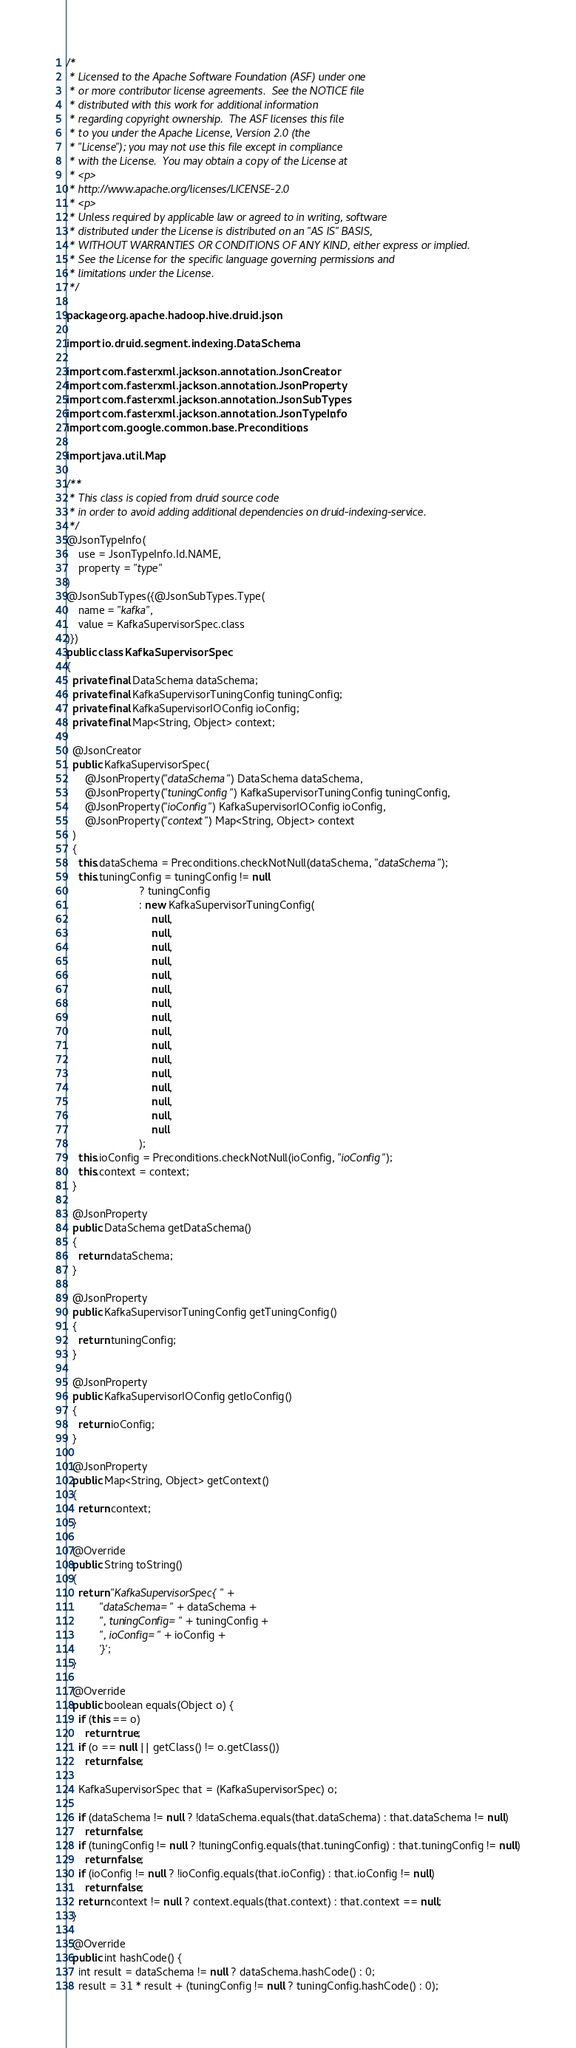<code> <loc_0><loc_0><loc_500><loc_500><_Java_>/*
 * Licensed to the Apache Software Foundation (ASF) under one
 * or more contributor license agreements.  See the NOTICE file
 * distributed with this work for additional information
 * regarding copyright ownership.  The ASF licenses this file
 * to you under the Apache License, Version 2.0 (the
 * "License"); you may not use this file except in compliance
 * with the License.  You may obtain a copy of the License at
 * <p>
 * http://www.apache.org/licenses/LICENSE-2.0
 * <p>
 * Unless required by applicable law or agreed to in writing, software
 * distributed under the License is distributed on an "AS IS" BASIS,
 * WITHOUT WARRANTIES OR CONDITIONS OF ANY KIND, either express or implied.
 * See the License for the specific language governing permissions and
 * limitations under the License.
 */

package org.apache.hadoop.hive.druid.json;

import io.druid.segment.indexing.DataSchema;

import com.fasterxml.jackson.annotation.JsonCreator;
import com.fasterxml.jackson.annotation.JsonProperty;
import com.fasterxml.jackson.annotation.JsonSubTypes;
import com.fasterxml.jackson.annotation.JsonTypeInfo;
import com.google.common.base.Preconditions;

import java.util.Map;

/**
 * This class is copied from druid source code
 * in order to avoid adding additional dependencies on druid-indexing-service.
 */
@JsonTypeInfo(
    use = JsonTypeInfo.Id.NAME,
    property = "type"
)
@JsonSubTypes({@JsonSubTypes.Type(
    name = "kafka",
    value = KafkaSupervisorSpec.class
)})
public class KafkaSupervisorSpec
{
  private final DataSchema dataSchema;
  private final KafkaSupervisorTuningConfig tuningConfig;
  private final KafkaSupervisorIOConfig ioConfig;
  private final Map<String, Object> context;

  @JsonCreator
  public KafkaSupervisorSpec(
      @JsonProperty("dataSchema") DataSchema dataSchema,
      @JsonProperty("tuningConfig") KafkaSupervisorTuningConfig tuningConfig,
      @JsonProperty("ioConfig") KafkaSupervisorIOConfig ioConfig,
      @JsonProperty("context") Map<String, Object> context
  )
  {
    this.dataSchema = Preconditions.checkNotNull(dataSchema, "dataSchema");
    this.tuningConfig = tuningConfig != null
                        ? tuningConfig
                        : new KafkaSupervisorTuningConfig(
                            null,
                            null,
                            null,
                            null,
                            null,
                            null,
                            null,
                            null,
                            null,
                            null,
                            null,
                            null,
                            null,
                            null,
                            null,
                            null
                        );
    this.ioConfig = Preconditions.checkNotNull(ioConfig, "ioConfig");
    this.context = context;
  }

  @JsonProperty
  public DataSchema getDataSchema()
  {
    return dataSchema;
  }

  @JsonProperty
  public KafkaSupervisorTuningConfig getTuningConfig()
  {
    return tuningConfig;
  }

  @JsonProperty
  public KafkaSupervisorIOConfig getIoConfig()
  {
    return ioConfig;
  }

  @JsonProperty
  public Map<String, Object> getContext()
  {
    return context;
  }

  @Override
  public String toString()
  {
    return "KafkaSupervisorSpec{" +
           "dataSchema=" + dataSchema +
           ", tuningConfig=" + tuningConfig +
           ", ioConfig=" + ioConfig +
           '}';
  }

  @Override
  public boolean equals(Object o) {
    if (this == o)
      return true;
    if (o == null || getClass() != o.getClass())
      return false;

    KafkaSupervisorSpec that = (KafkaSupervisorSpec) o;

    if (dataSchema != null ? !dataSchema.equals(that.dataSchema) : that.dataSchema != null)
      return false;
    if (tuningConfig != null ? !tuningConfig.equals(that.tuningConfig) : that.tuningConfig != null)
      return false;
    if (ioConfig != null ? !ioConfig.equals(that.ioConfig) : that.ioConfig != null)
      return false;
    return context != null ? context.equals(that.context) : that.context == null;
  }

  @Override
  public int hashCode() {
    int result = dataSchema != null ? dataSchema.hashCode() : 0;
    result = 31 * result + (tuningConfig != null ? tuningConfig.hashCode() : 0);</code> 